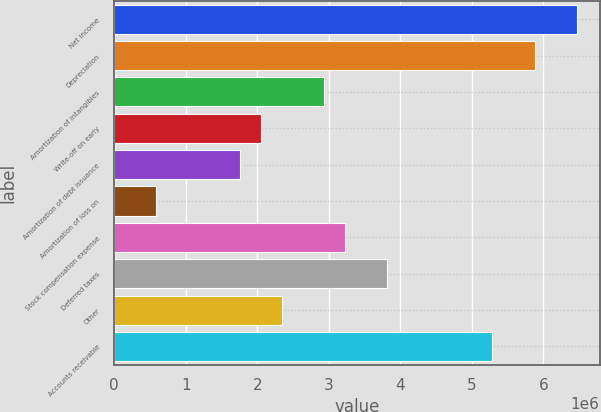Convert chart. <chart><loc_0><loc_0><loc_500><loc_500><bar_chart><fcel>Net income<fcel>Depreciation<fcel>Amortization of intangibles<fcel>Write-off on early<fcel>Amortization of debt issuance<fcel>Amortization of loss on<fcel>Stock compensation expense<fcel>Deferred taxes<fcel>Other<fcel>Accounts receivable<nl><fcel>6.46419e+06<fcel>5.87658e+06<fcel>2.9385e+06<fcel>2.05708e+06<fcel>1.76327e+06<fcel>588039<fcel>3.23231e+06<fcel>3.81992e+06<fcel>2.35088e+06<fcel>5.28896e+06<nl></chart> 